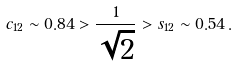Convert formula to latex. <formula><loc_0><loc_0><loc_500><loc_500>c _ { 1 2 } \sim 0 . 8 4 > \frac { 1 } { \sqrt { 2 } } > s _ { 1 2 } \sim 0 . 5 4 \, .</formula> 